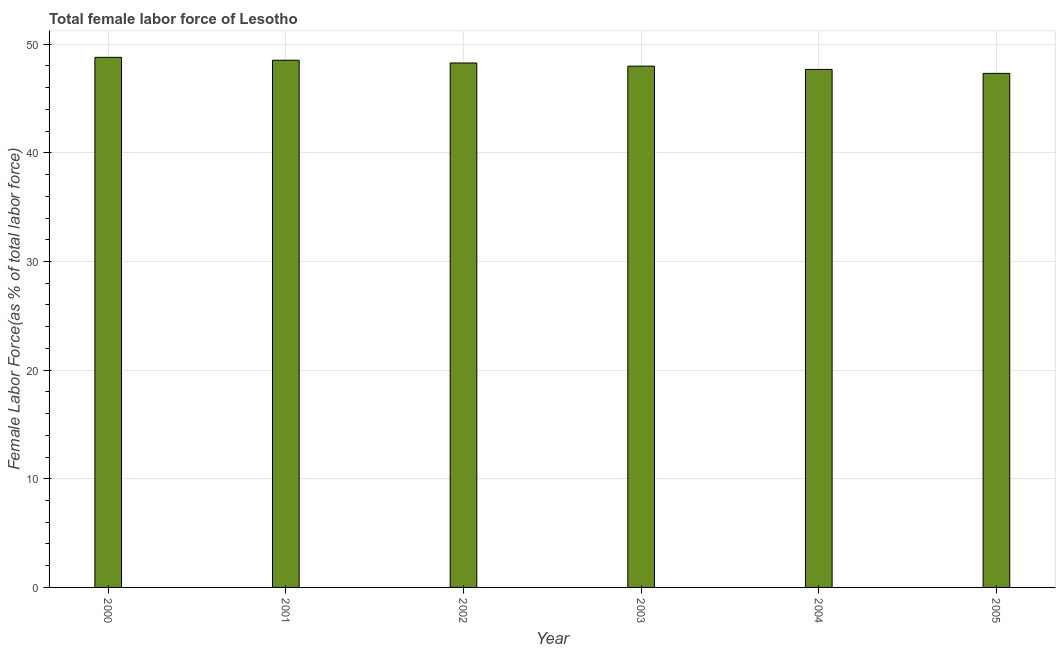Does the graph contain any zero values?
Offer a terse response. No. What is the title of the graph?
Ensure brevity in your answer.  Total female labor force of Lesotho. What is the label or title of the Y-axis?
Your answer should be compact. Female Labor Force(as % of total labor force). What is the total female labor force in 2001?
Give a very brief answer. 48.53. Across all years, what is the maximum total female labor force?
Offer a very short reply. 48.8. Across all years, what is the minimum total female labor force?
Provide a succinct answer. 47.32. In which year was the total female labor force maximum?
Ensure brevity in your answer.  2000. In which year was the total female labor force minimum?
Provide a succinct answer. 2005. What is the sum of the total female labor force?
Give a very brief answer. 288.6. What is the difference between the total female labor force in 2003 and 2005?
Provide a short and direct response. 0.67. What is the average total female labor force per year?
Your answer should be very brief. 48.1. What is the median total female labor force?
Your answer should be very brief. 48.13. Is the total female labor force in 2004 less than that in 2005?
Provide a succinct answer. No. Is the difference between the total female labor force in 2001 and 2003 greater than the difference between any two years?
Make the answer very short. No. What is the difference between the highest and the second highest total female labor force?
Offer a very short reply. 0.27. Is the sum of the total female labor force in 2000 and 2002 greater than the maximum total female labor force across all years?
Ensure brevity in your answer.  Yes. What is the difference between the highest and the lowest total female labor force?
Ensure brevity in your answer.  1.48. In how many years, is the total female labor force greater than the average total female labor force taken over all years?
Keep it short and to the point. 3. Are all the bars in the graph horizontal?
Offer a very short reply. No. Are the values on the major ticks of Y-axis written in scientific E-notation?
Your response must be concise. No. What is the Female Labor Force(as % of total labor force) of 2000?
Your answer should be very brief. 48.8. What is the Female Labor Force(as % of total labor force) in 2001?
Give a very brief answer. 48.53. What is the Female Labor Force(as % of total labor force) in 2002?
Your answer should be very brief. 48.28. What is the Female Labor Force(as % of total labor force) in 2003?
Your answer should be compact. 47.99. What is the Female Labor Force(as % of total labor force) of 2004?
Your answer should be compact. 47.68. What is the Female Labor Force(as % of total labor force) in 2005?
Give a very brief answer. 47.32. What is the difference between the Female Labor Force(as % of total labor force) in 2000 and 2001?
Provide a succinct answer. 0.27. What is the difference between the Female Labor Force(as % of total labor force) in 2000 and 2002?
Your answer should be very brief. 0.52. What is the difference between the Female Labor Force(as % of total labor force) in 2000 and 2003?
Your answer should be compact. 0.81. What is the difference between the Female Labor Force(as % of total labor force) in 2000 and 2004?
Offer a terse response. 1.11. What is the difference between the Female Labor Force(as % of total labor force) in 2000 and 2005?
Your response must be concise. 1.48. What is the difference between the Female Labor Force(as % of total labor force) in 2001 and 2002?
Make the answer very short. 0.25. What is the difference between the Female Labor Force(as % of total labor force) in 2001 and 2003?
Your answer should be very brief. 0.54. What is the difference between the Female Labor Force(as % of total labor force) in 2001 and 2004?
Give a very brief answer. 0.85. What is the difference between the Female Labor Force(as % of total labor force) in 2001 and 2005?
Your response must be concise. 1.21. What is the difference between the Female Labor Force(as % of total labor force) in 2002 and 2003?
Provide a succinct answer. 0.29. What is the difference between the Female Labor Force(as % of total labor force) in 2002 and 2004?
Provide a short and direct response. 0.59. What is the difference between the Female Labor Force(as % of total labor force) in 2002 and 2005?
Your response must be concise. 0.96. What is the difference between the Female Labor Force(as % of total labor force) in 2003 and 2004?
Your response must be concise. 0.3. What is the difference between the Female Labor Force(as % of total labor force) in 2003 and 2005?
Give a very brief answer. 0.67. What is the difference between the Female Labor Force(as % of total labor force) in 2004 and 2005?
Make the answer very short. 0.36. What is the ratio of the Female Labor Force(as % of total labor force) in 2000 to that in 2001?
Provide a succinct answer. 1. What is the ratio of the Female Labor Force(as % of total labor force) in 2000 to that in 2002?
Provide a short and direct response. 1.01. What is the ratio of the Female Labor Force(as % of total labor force) in 2000 to that in 2003?
Your answer should be compact. 1.02. What is the ratio of the Female Labor Force(as % of total labor force) in 2000 to that in 2004?
Your answer should be very brief. 1.02. What is the ratio of the Female Labor Force(as % of total labor force) in 2000 to that in 2005?
Make the answer very short. 1.03. What is the ratio of the Female Labor Force(as % of total labor force) in 2001 to that in 2004?
Your answer should be very brief. 1.02. What is the ratio of the Female Labor Force(as % of total labor force) in 2002 to that in 2003?
Give a very brief answer. 1.01. What is the ratio of the Female Labor Force(as % of total labor force) in 2002 to that in 2005?
Your answer should be very brief. 1.02. 